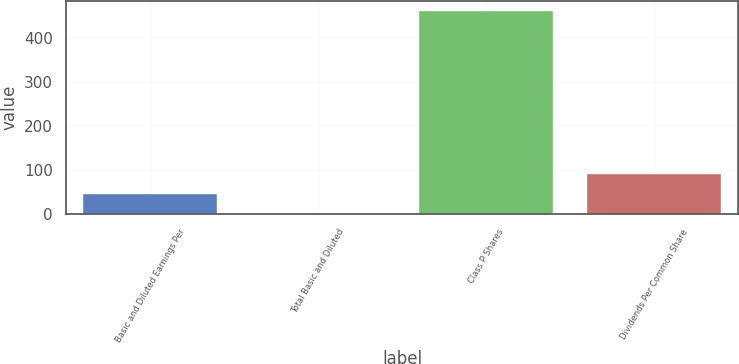<chart> <loc_0><loc_0><loc_500><loc_500><bar_chart><fcel>Basic and Diluted Earnings Per<fcel>Total Basic and Diluted<fcel>Class P Shares<fcel>Dividends Per Common Share<nl><fcel>46.41<fcel>0.35<fcel>461<fcel>92.47<nl></chart> 